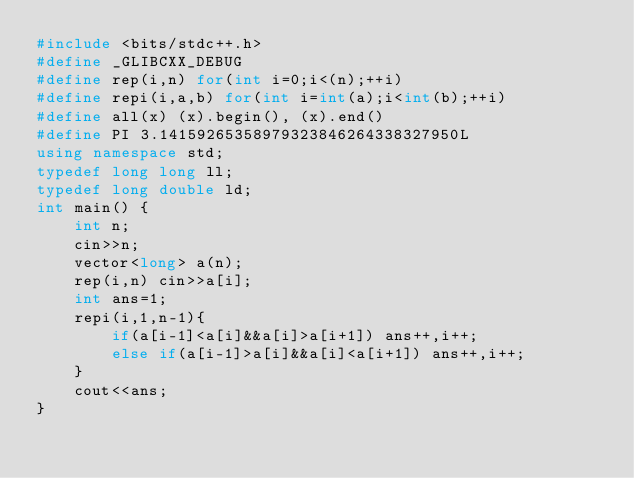Convert code to text. <code><loc_0><loc_0><loc_500><loc_500><_C++_>#include <bits/stdc++.h>
#define _GLIBCXX_DEBUG
#define rep(i,n) for(int i=0;i<(n);++i)
#define repi(i,a,b) for(int i=int(a);i<int(b);++i)
#define all(x) (x).begin(), (x).end()
#define PI 3.14159265358979323846264338327950L
using namespace std;
typedef long long ll;
typedef long double ld;
int main() {
    int n;
    cin>>n;
    vector<long> a(n);
    rep(i,n) cin>>a[i];
    int ans=1;
    repi(i,1,n-1){
        if(a[i-1]<a[i]&&a[i]>a[i+1]) ans++,i++;
        else if(a[i-1]>a[i]&&a[i]<a[i+1]) ans++,i++;
    }
    cout<<ans;
}</code> 